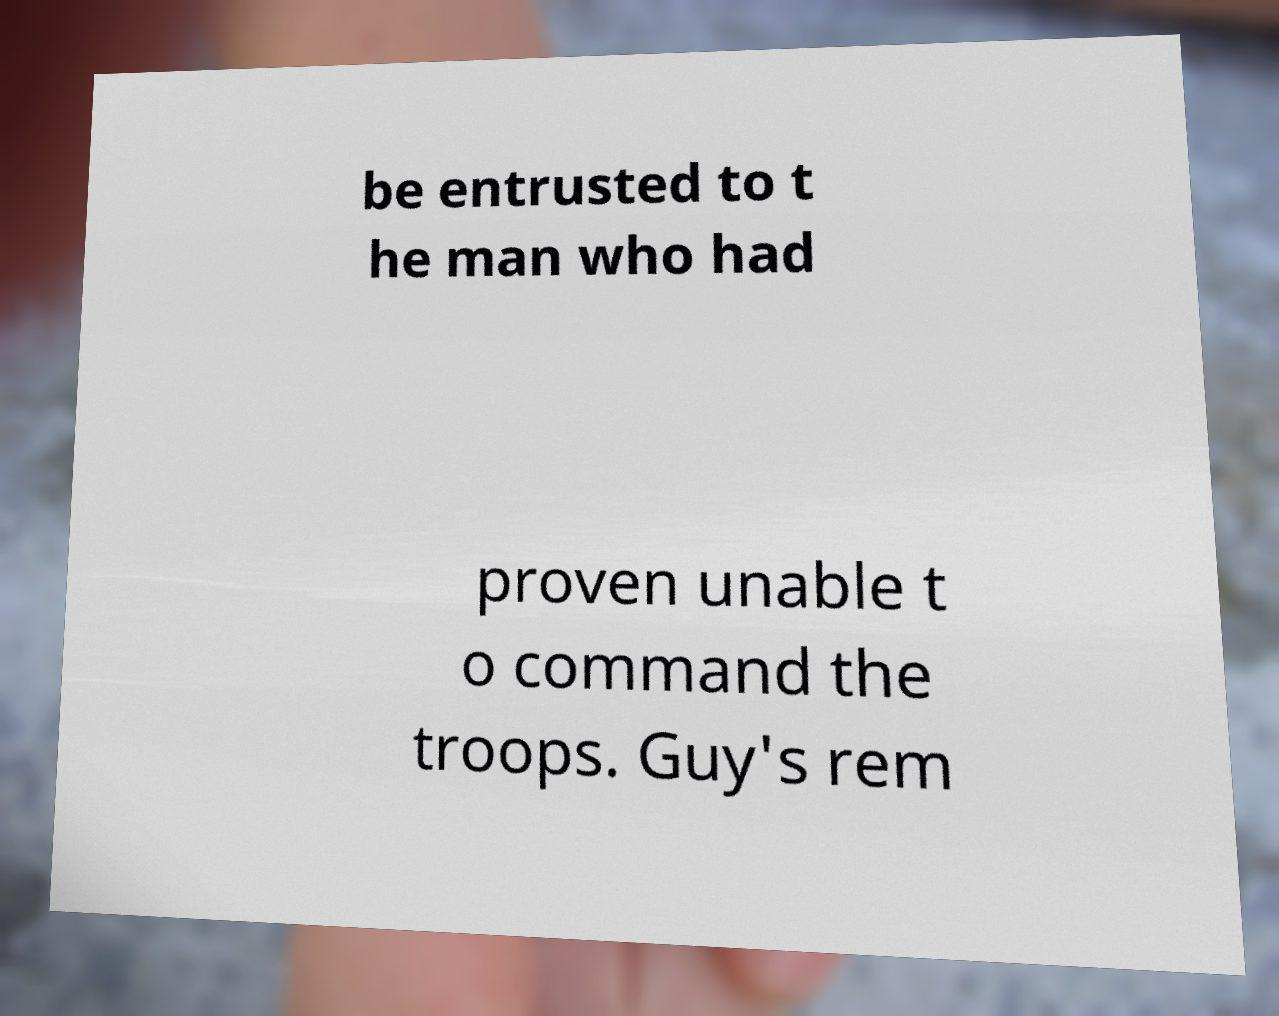Can you read and provide the text displayed in the image?This photo seems to have some interesting text. Can you extract and type it out for me? be entrusted to t he man who had proven unable t o command the troops. Guy's rem 